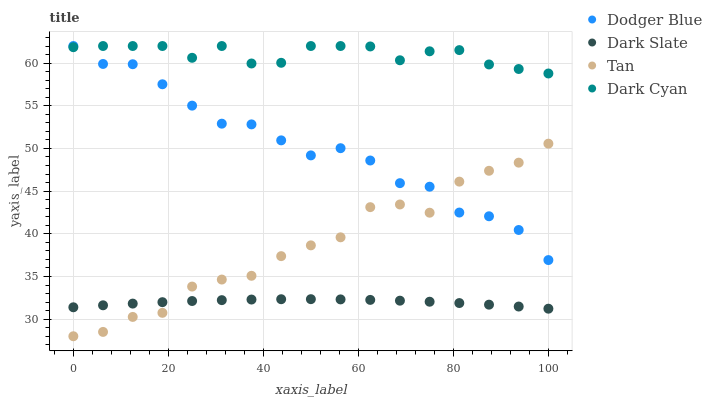Does Dark Slate have the minimum area under the curve?
Answer yes or no. Yes. Does Dark Cyan have the maximum area under the curve?
Answer yes or no. Yes. Does Tan have the minimum area under the curve?
Answer yes or no. No. Does Tan have the maximum area under the curve?
Answer yes or no. No. Is Dark Slate the smoothest?
Answer yes or no. Yes. Is Tan the roughest?
Answer yes or no. Yes. Is Tan the smoothest?
Answer yes or no. No. Is Dark Slate the roughest?
Answer yes or no. No. Does Tan have the lowest value?
Answer yes or no. Yes. Does Dark Slate have the lowest value?
Answer yes or no. No. Does Dodger Blue have the highest value?
Answer yes or no. Yes. Does Tan have the highest value?
Answer yes or no. No. Is Tan less than Dark Cyan?
Answer yes or no. Yes. Is Dark Cyan greater than Dark Slate?
Answer yes or no. Yes. Does Dark Slate intersect Tan?
Answer yes or no. Yes. Is Dark Slate less than Tan?
Answer yes or no. No. Is Dark Slate greater than Tan?
Answer yes or no. No. Does Tan intersect Dark Cyan?
Answer yes or no. No. 